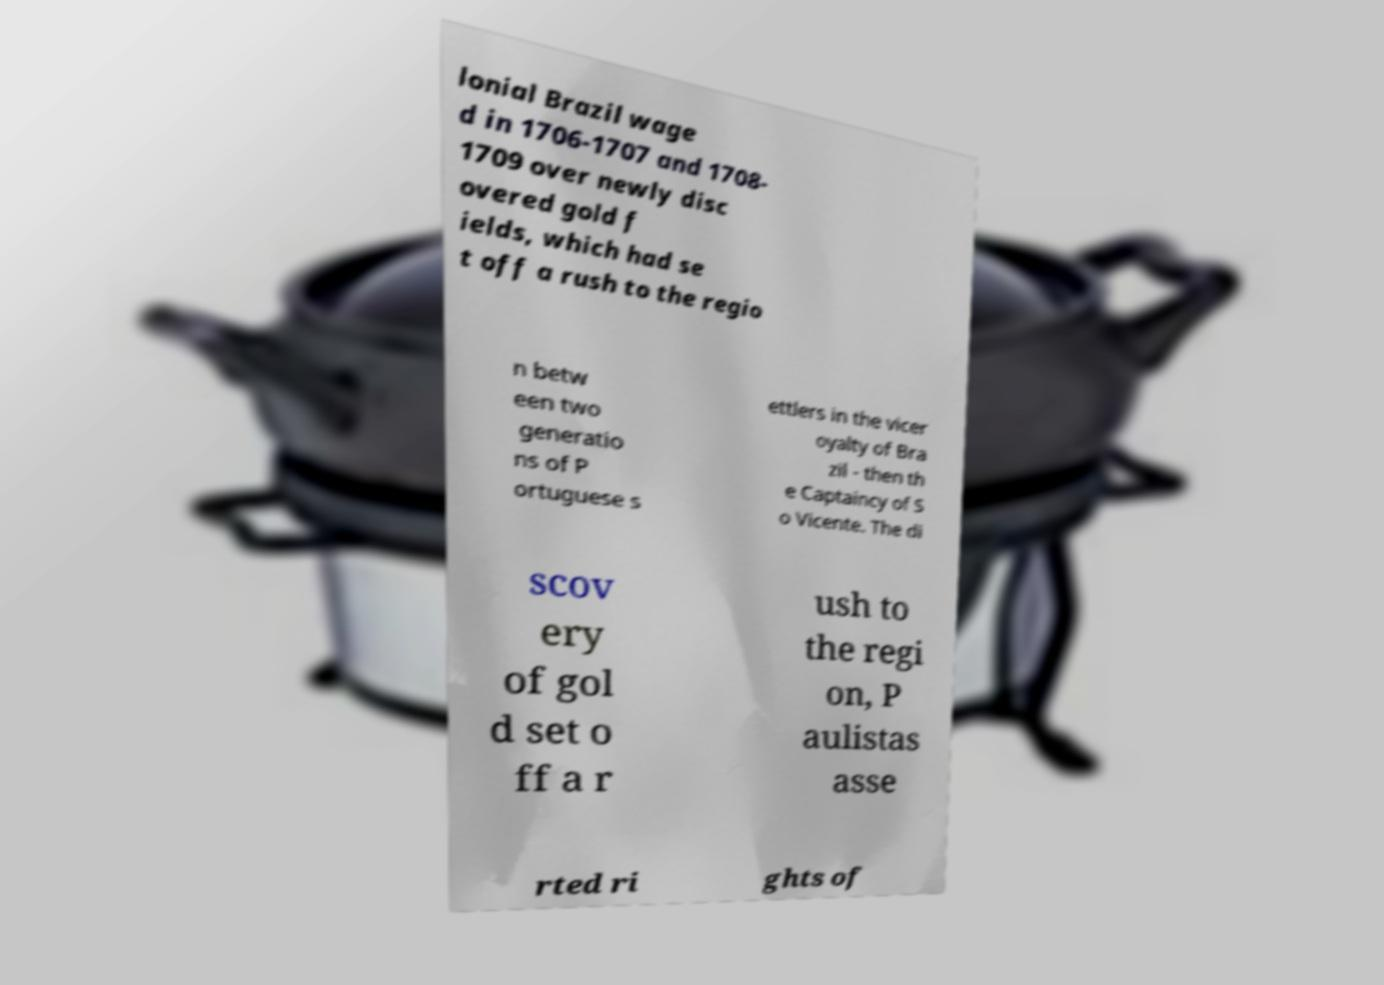There's text embedded in this image that I need extracted. Can you transcribe it verbatim? lonial Brazil wage d in 1706-1707 and 1708- 1709 over newly disc overed gold f ields, which had se t off a rush to the regio n betw een two generatio ns of P ortuguese s ettlers in the vicer oyalty of Bra zil - then th e Captaincy of S o Vicente. The di scov ery of gol d set o ff a r ush to the regi on, P aulistas asse rted ri ghts of 